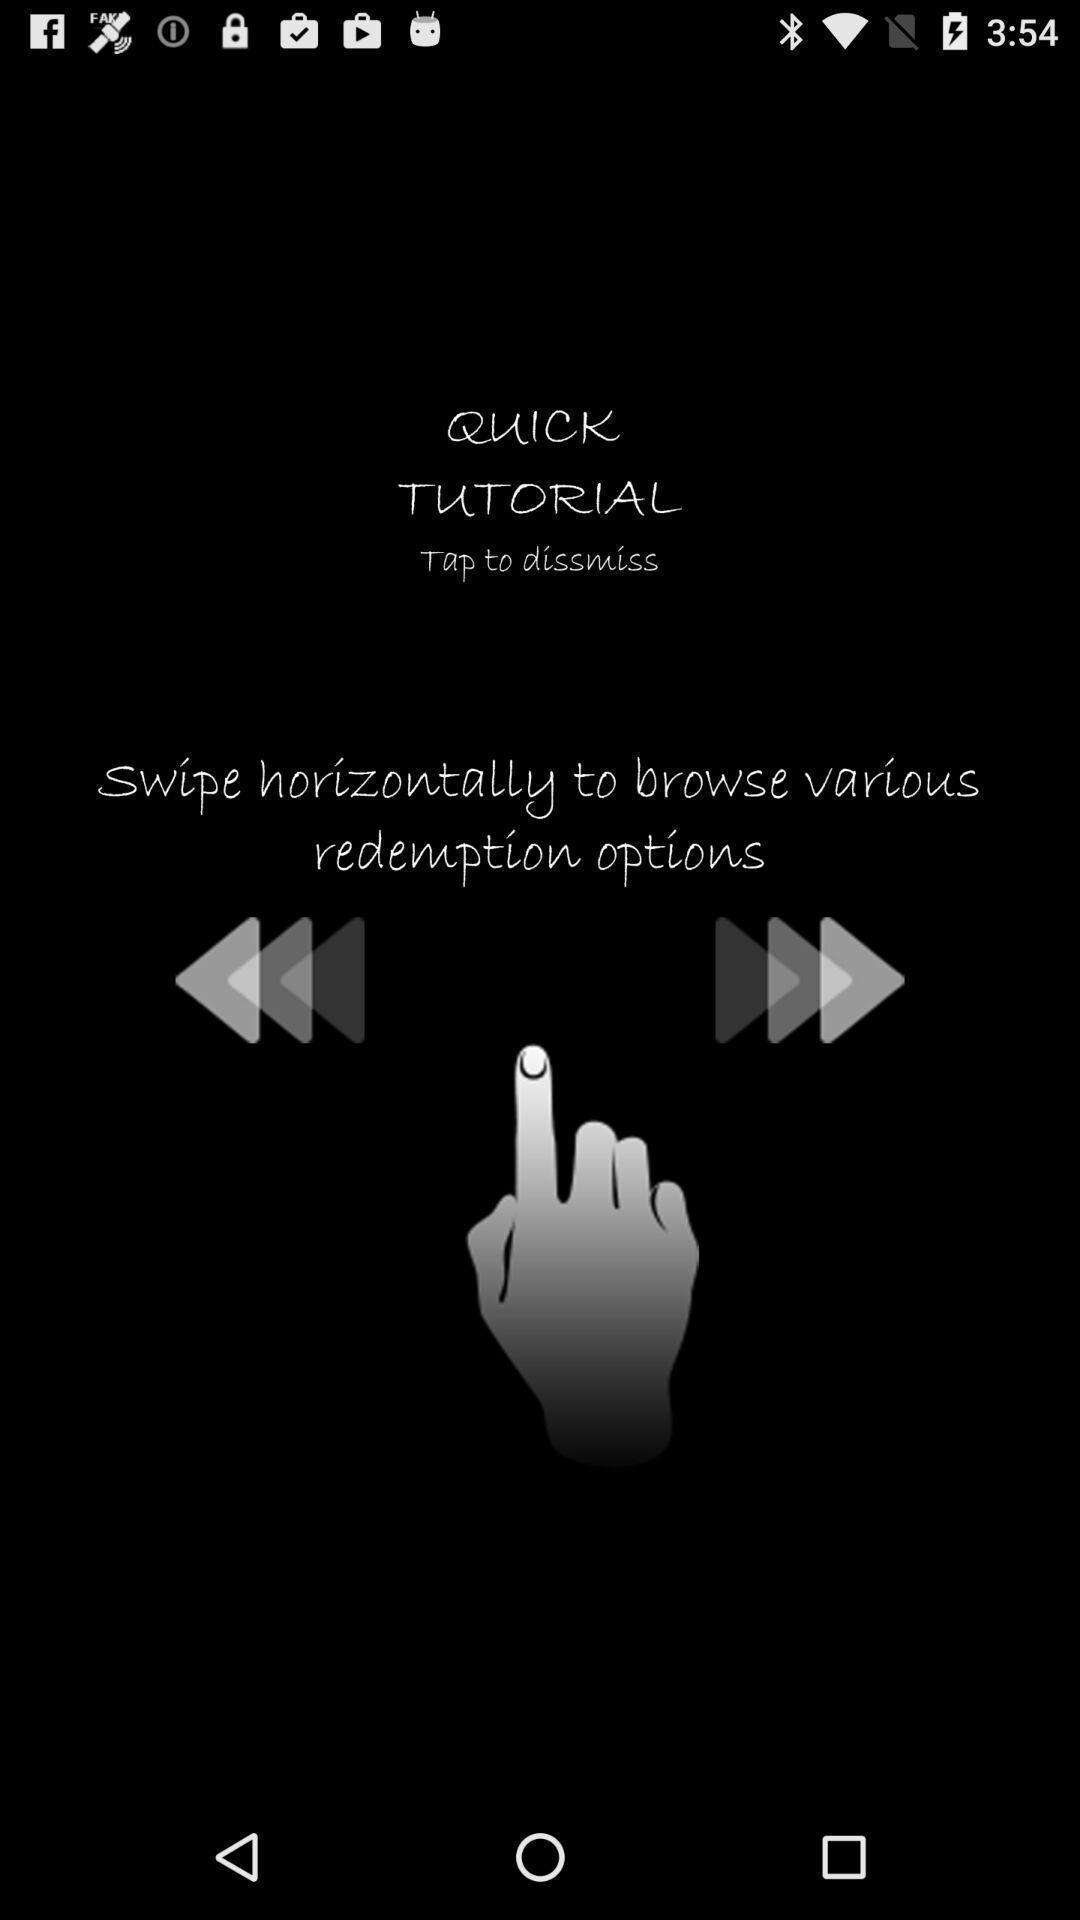Please provide a description for this image. Tutorial page for an application. 